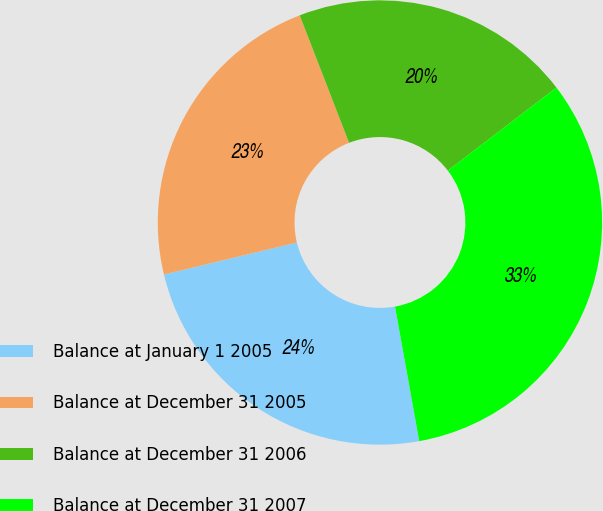<chart> <loc_0><loc_0><loc_500><loc_500><pie_chart><fcel>Balance at January 1 2005<fcel>Balance at December 31 2005<fcel>Balance at December 31 2006<fcel>Balance at December 31 2007<nl><fcel>24.07%<fcel>22.88%<fcel>20.49%<fcel>32.56%<nl></chart> 